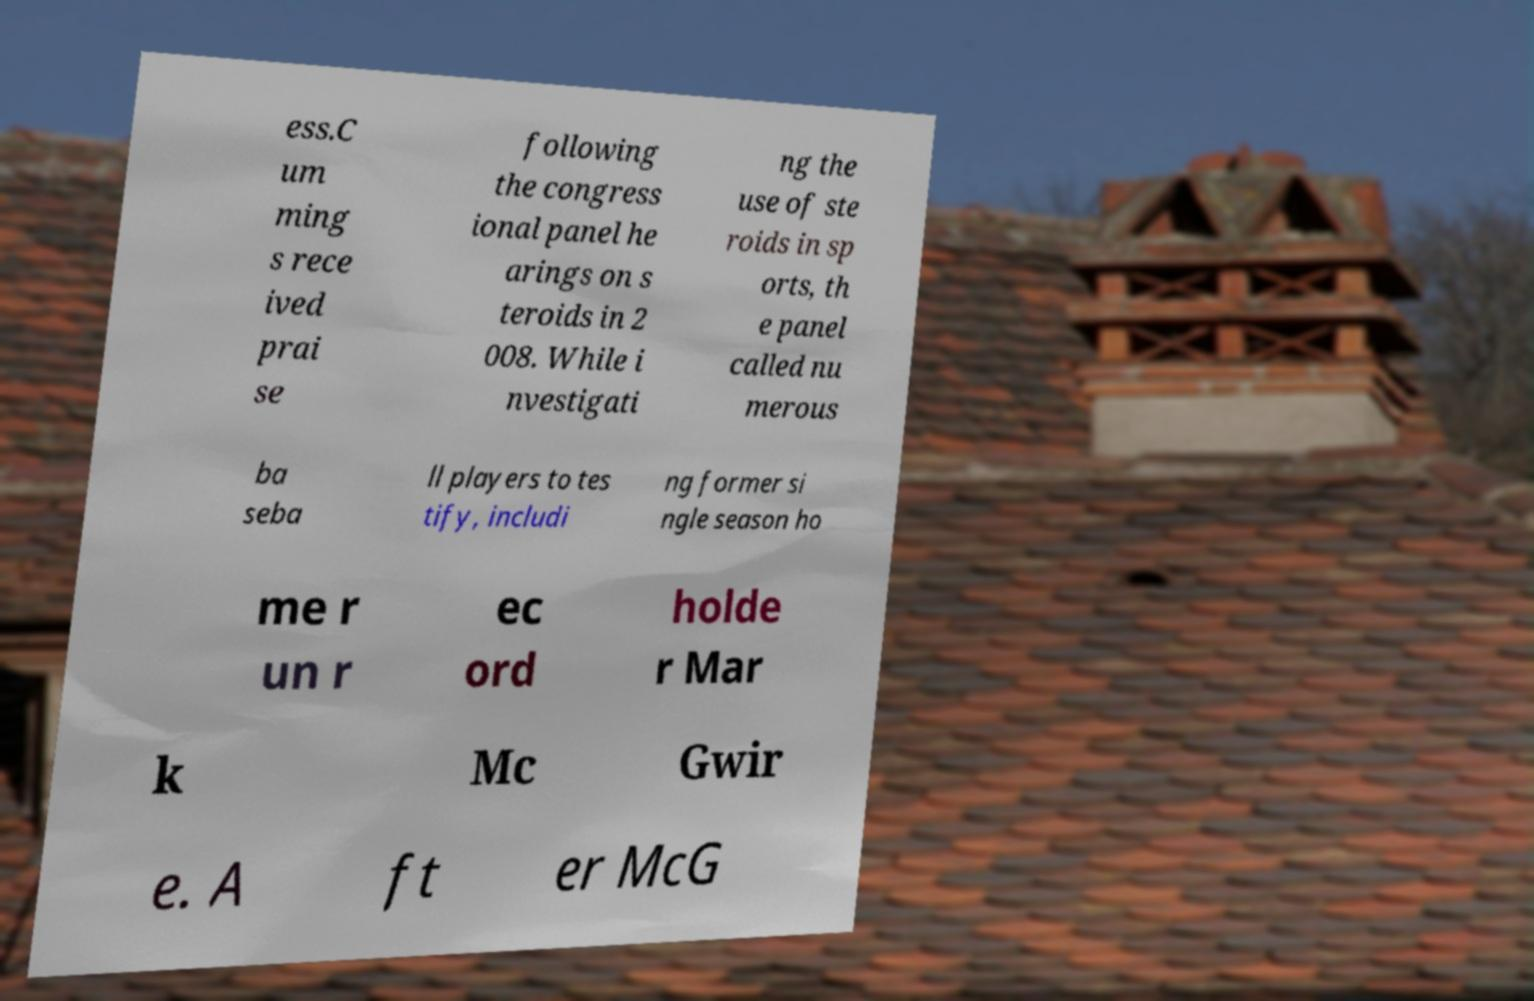Please identify and transcribe the text found in this image. ess.C um ming s rece ived prai se following the congress ional panel he arings on s teroids in 2 008. While i nvestigati ng the use of ste roids in sp orts, th e panel called nu merous ba seba ll players to tes tify, includi ng former si ngle season ho me r un r ec ord holde r Mar k Mc Gwir e. A ft er McG 